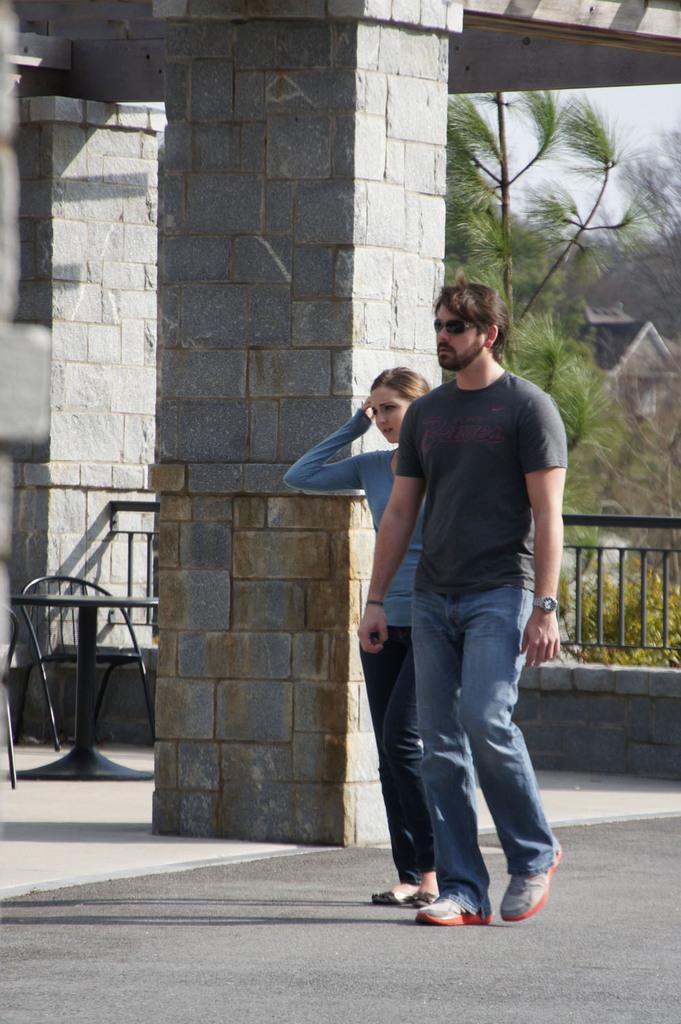How would you summarize this image in a sentence or two? In the image we can see there are two people who are standing on this road and beside them there is a pillar which is made up of stones and behind them there is a tree and buildings. 